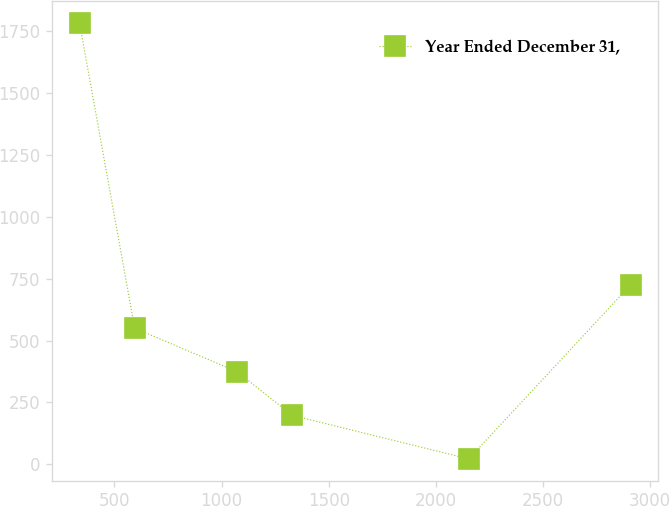Convert chart. <chart><loc_0><loc_0><loc_500><loc_500><line_chart><ecel><fcel>Year Ended December 31,<nl><fcel>336.96<fcel>1784.32<nl><fcel>594.32<fcel>550.33<nl><fcel>1072.54<fcel>374.04<nl><fcel>1329.9<fcel>197.75<nl><fcel>2153.51<fcel>21.46<nl><fcel>2910.56<fcel>726.62<nl></chart> 